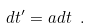<formula> <loc_0><loc_0><loc_500><loc_500>d t ^ { \prime } = a d t \ .</formula> 